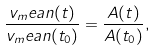<formula> <loc_0><loc_0><loc_500><loc_500>\frac { v _ { m } e a n ( t ) } { v _ { m } e a n ( t _ { 0 } ) } = \frac { A ( t ) } { A ( t _ { 0 } ) } ,</formula> 